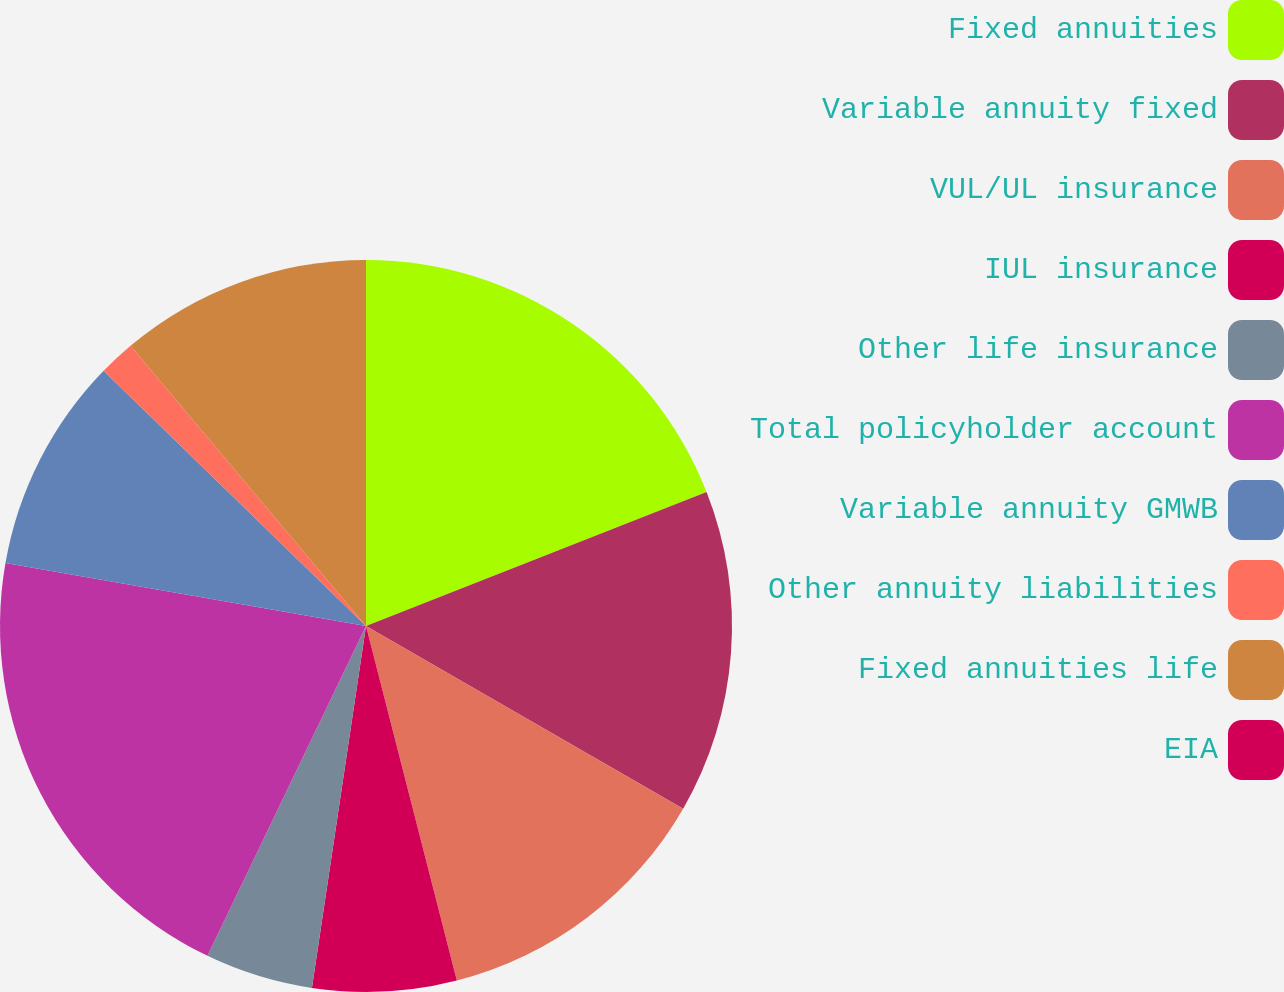Convert chart to OTSL. <chart><loc_0><loc_0><loc_500><loc_500><pie_chart><fcel>Fixed annuities<fcel>Variable annuity fixed<fcel>VUL/UL insurance<fcel>IUL insurance<fcel>Other life insurance<fcel>Total policyholder account<fcel>Variable annuity GMWB<fcel>Other annuity liabilities<fcel>Fixed annuities life<fcel>EIA<nl><fcel>19.03%<fcel>14.28%<fcel>12.69%<fcel>6.35%<fcel>4.77%<fcel>20.62%<fcel>9.52%<fcel>1.6%<fcel>11.11%<fcel>0.01%<nl></chart> 